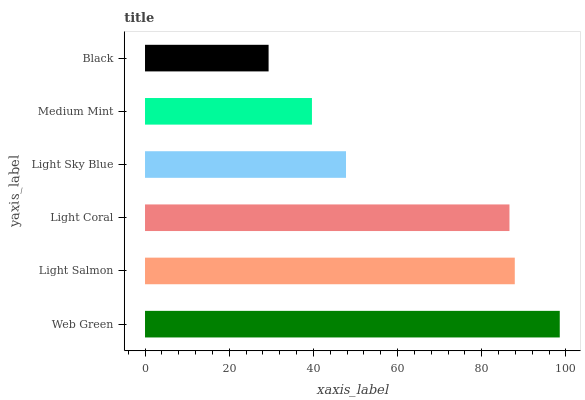Is Black the minimum?
Answer yes or no. Yes. Is Web Green the maximum?
Answer yes or no. Yes. Is Light Salmon the minimum?
Answer yes or no. No. Is Light Salmon the maximum?
Answer yes or no. No. Is Web Green greater than Light Salmon?
Answer yes or no. Yes. Is Light Salmon less than Web Green?
Answer yes or no. Yes. Is Light Salmon greater than Web Green?
Answer yes or no. No. Is Web Green less than Light Salmon?
Answer yes or no. No. Is Light Coral the high median?
Answer yes or no. Yes. Is Light Sky Blue the low median?
Answer yes or no. Yes. Is Light Sky Blue the high median?
Answer yes or no. No. Is Light Salmon the low median?
Answer yes or no. No. 